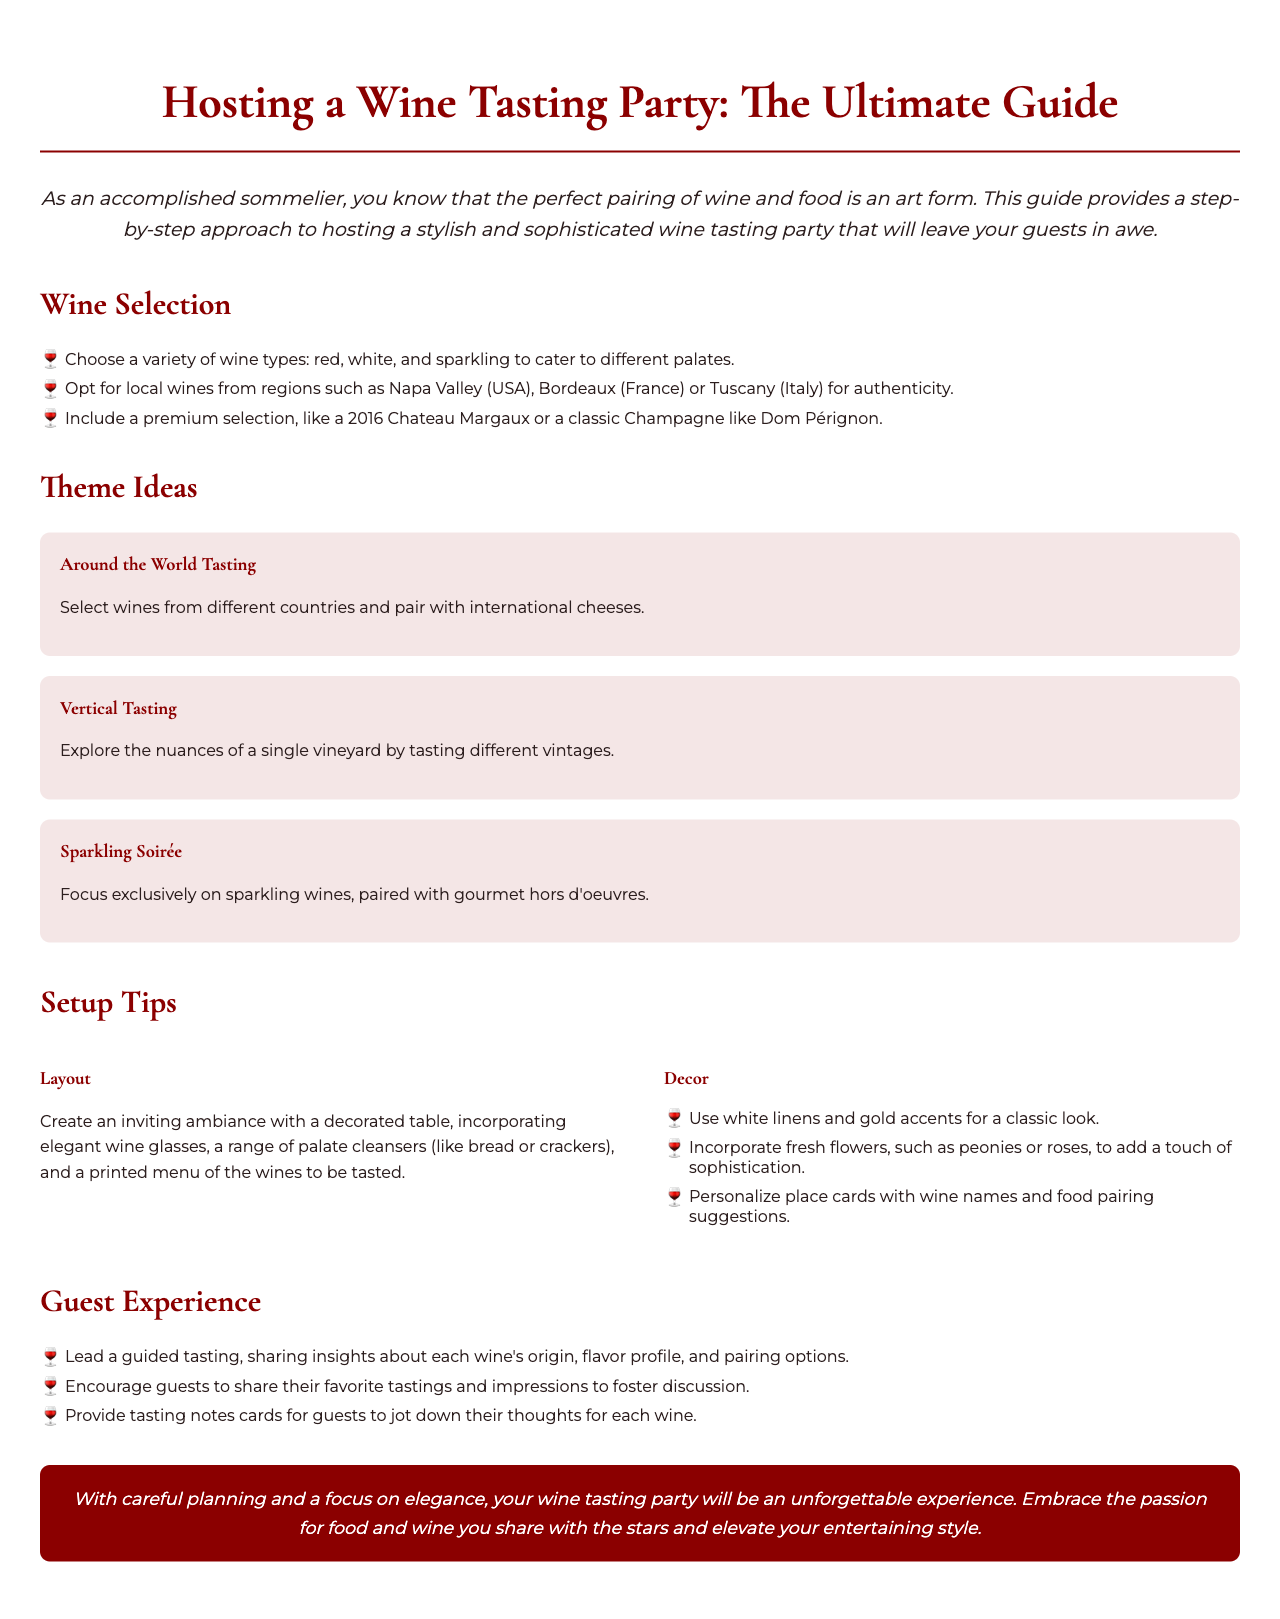what is the title of the guide? The title of the guide is prominently displayed at the top of the document.
Answer: Hosting a Wine Tasting Party: The Ultimate Guide what is mentioned as the ideal wine selection to cater to different palates? The document specifies that choosing a variety of wine types is essential for catering to different palates.
Answer: red, white, and sparkling which wine is suggested as a premium selection? A specific premium wine is recommended within the context of the wine selection.
Answer: 2016 Chateau Margaux what is one of the theme ideas for the wine tasting? The document lists several theme ideas for a wine tasting, one of which is highlighted.
Answer: Around the World Tasting how should the table be decorated according to the setup tips? The document provides guidance on how to create an inviting ambiance with specific decor details.
Answer: white linens and gold accents what type of flowers is suggested for decor? The document recommends a type of flower to enhance the sophistication of the event.
Answer: peonies or roses how should guests be encouraged to participate during the tasting? The guide suggests a way to enhance guest participation and interaction during the event.
Answer: share their favorite tastings and impressions what is the main focus of the conclusion? The conclusion summarizes the primary aim and result of hosting the event as mentioned in the document.
Answer: unforgettable experience 